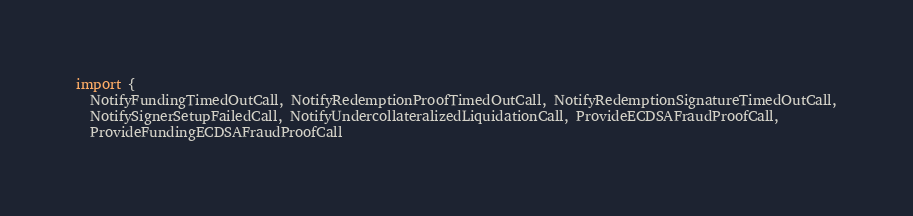<code> <loc_0><loc_0><loc_500><loc_500><_TypeScript_>import {
  NotifyFundingTimedOutCall, NotifyRedemptionProofTimedOutCall, NotifyRedemptionSignatureTimedOutCall,
  NotifySignerSetupFailedCall, NotifyUndercollateralizedLiquidationCall, ProvideECDSAFraudProofCall,
  ProvideFundingECDSAFraudProofCall</code> 